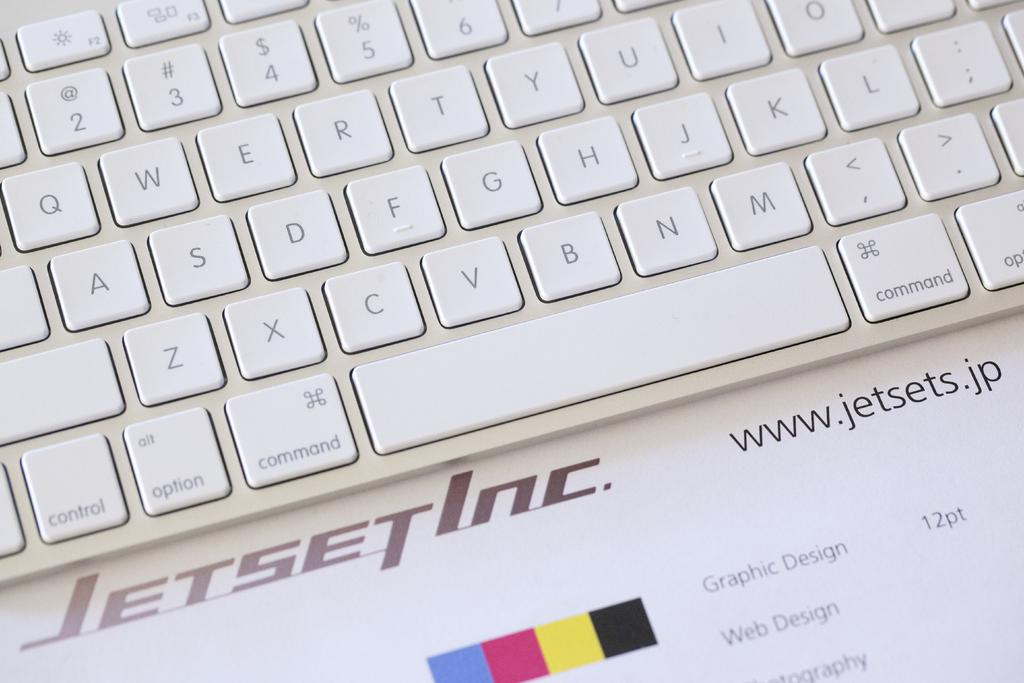Provide a one-sentence caption for the provided image. a white keyboard is sitting on an ad for jetset inc. 